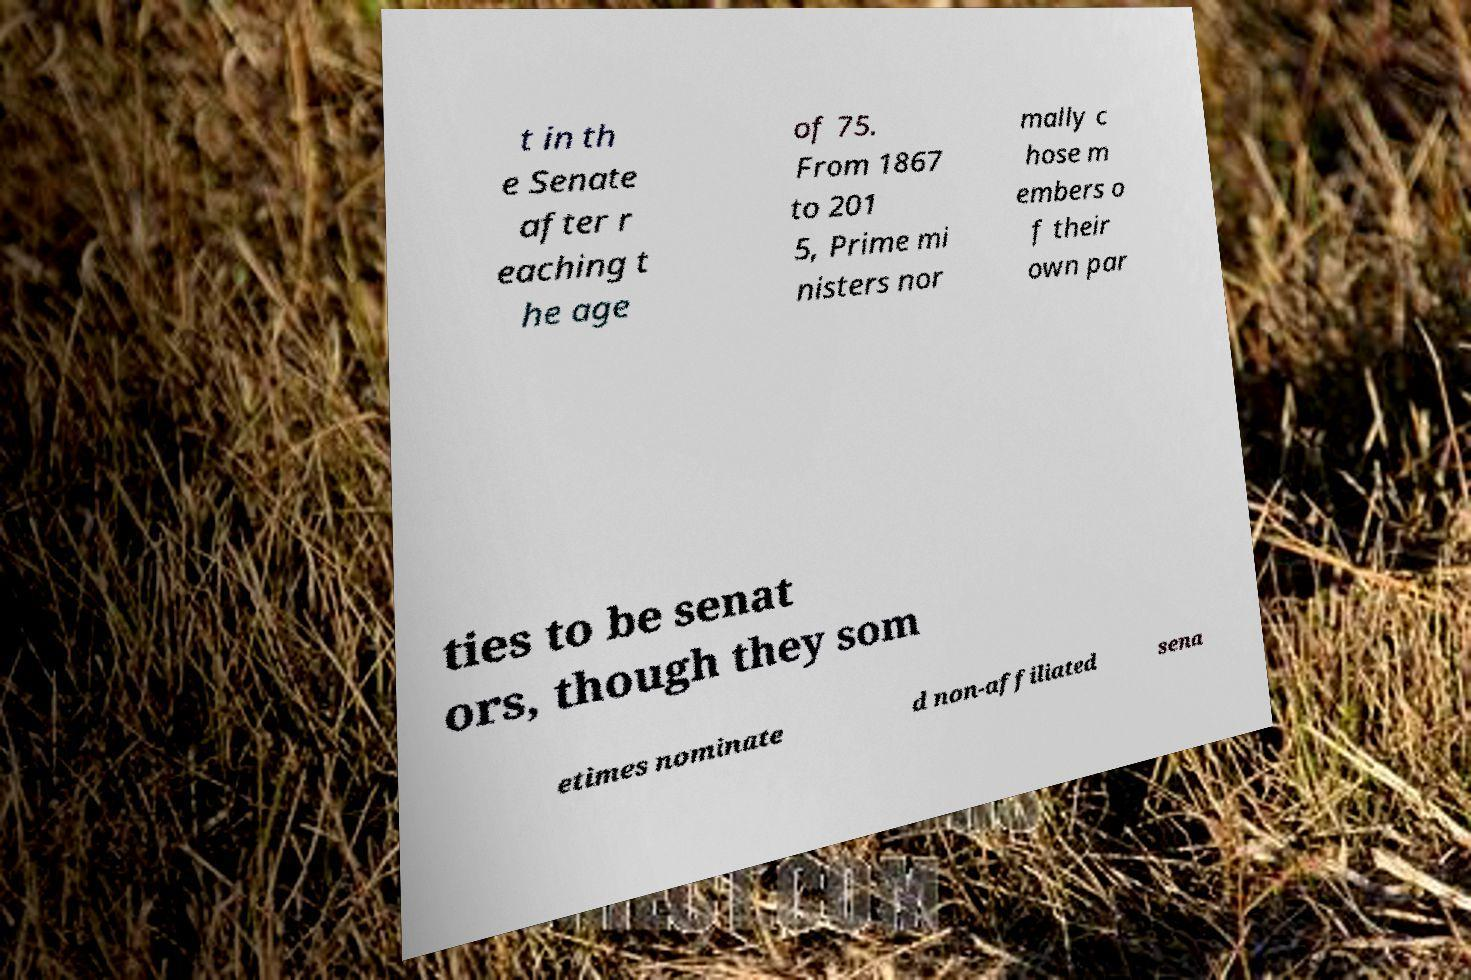Please identify and transcribe the text found in this image. t in th e Senate after r eaching t he age of 75. From 1867 to 201 5, Prime mi nisters nor mally c hose m embers o f their own par ties to be senat ors, though they som etimes nominate d non-affiliated sena 